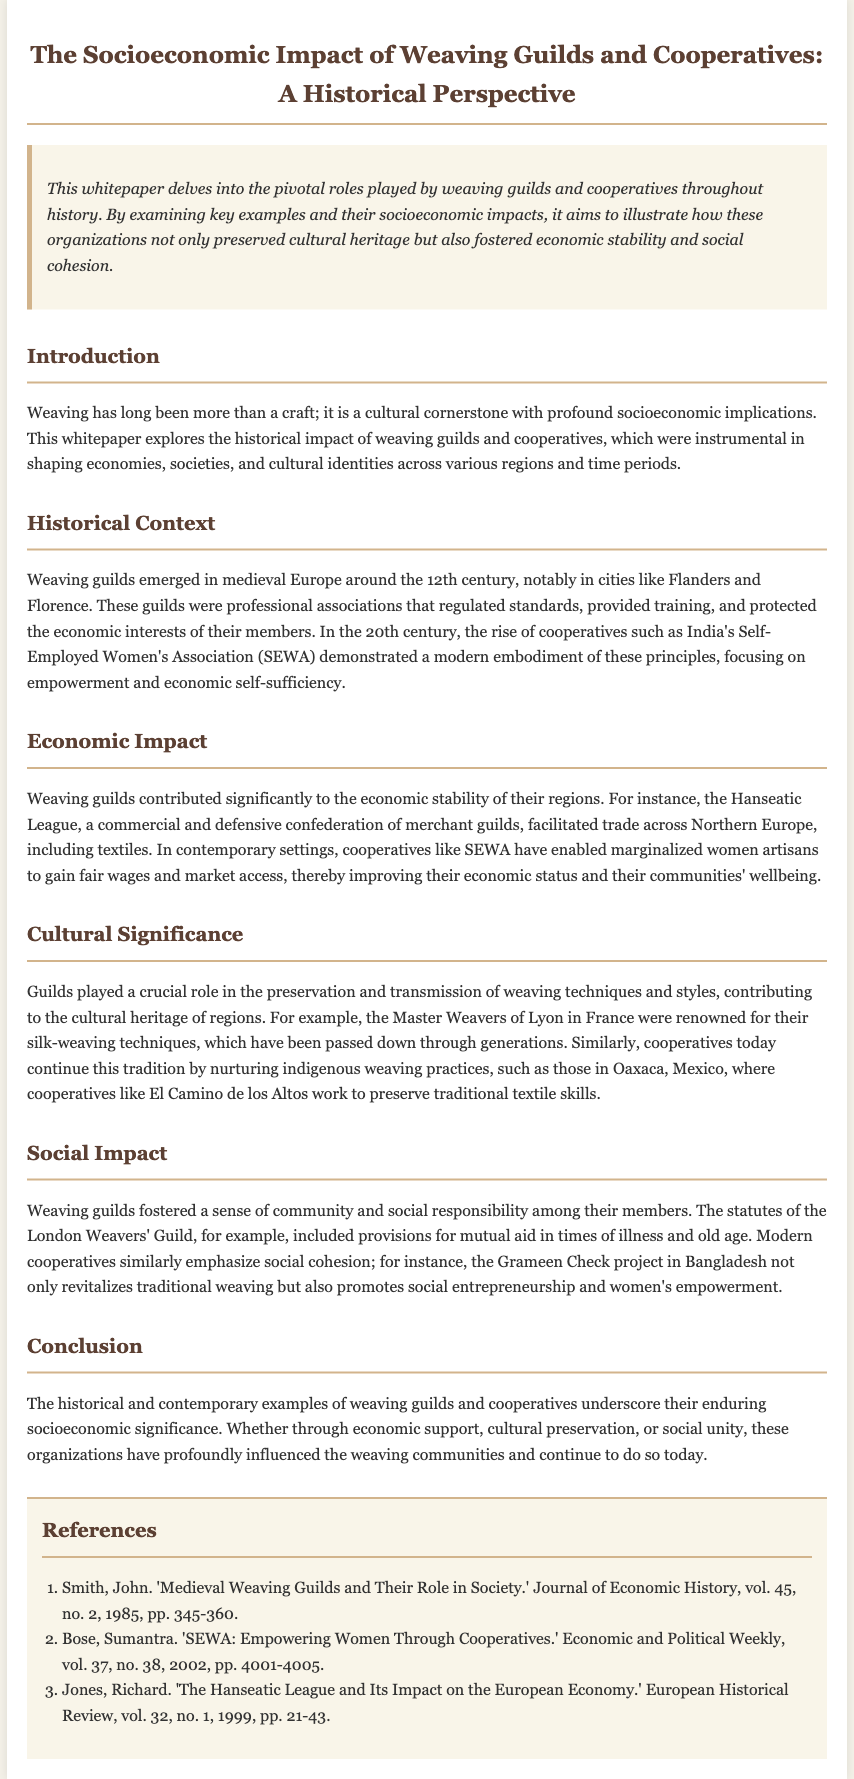What century did weaving guilds emerge in Europe? The document states that weaving guilds emerged around the 12th century in medieval Europe.
Answer: 12th century What was the focus of India's SEWA? The document mentions that SEWA focuses on empowerment and economic self-sufficiency for women.
Answer: Empowerment and economic self-sufficiency Which confederation facilitated trade across Northern Europe? The document refers to the Hanseatic League as a confederation that facilitated trade.
Answer: Hanseatic League What is the cultural significance of the Master Weavers of Lyon? The document notes that the Master Weavers of Lyon were renowned for their silk-weaving techniques.
Answer: Silk-weaving techniques What type of provisions did the London Weavers' Guild include? The document indicates that the statutes of the London Weavers' Guild included provisions for mutual aid.
Answer: Mutual aid What project in Bangladesh promotes social entrepreneurship? The document cites the Grameen Check project in Bangladesh as promoting social entrepreneurship.
Answer: Grameen Check What type of organizations have historically influenced weaving communities? The document emphasizes that weaving guilds and cooperatives have historically influenced these communities.
Answer: Weaving guilds and cooperatives What is the overarching theme of the whitepaper? The document states that the whitepaper delves into the pivotal roles played by weaving guilds and cooperatives.
Answer: Pivotal roles played by weaving guilds and cooperatives How many references are listed in the document? The document contains a list of references at the end, and by counting them, we find there are three.
Answer: Three 